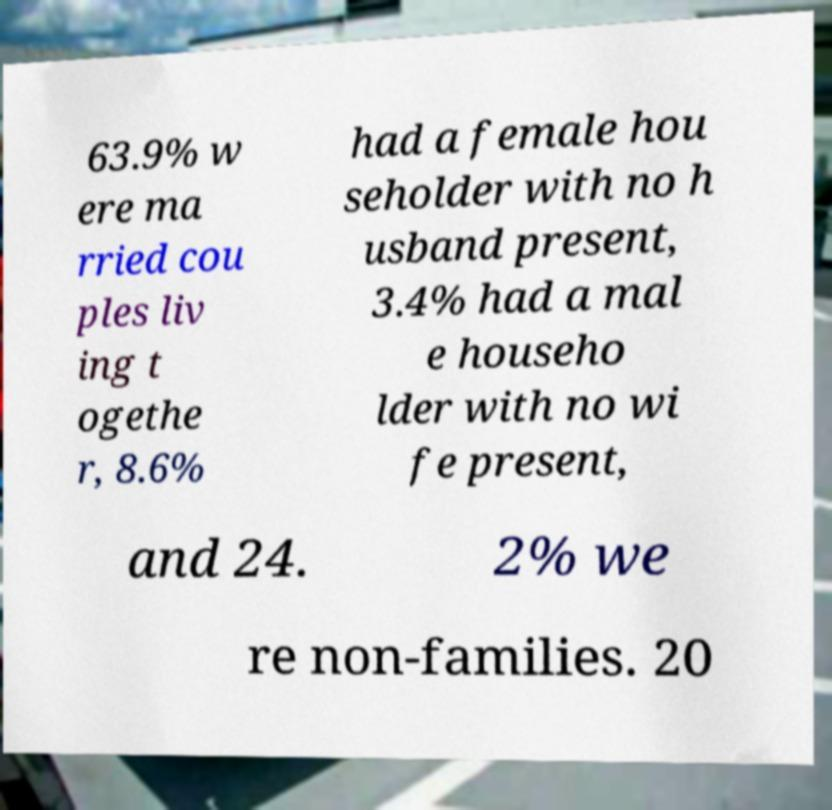Please identify and transcribe the text found in this image. 63.9% w ere ma rried cou ples liv ing t ogethe r, 8.6% had a female hou seholder with no h usband present, 3.4% had a mal e househo lder with no wi fe present, and 24. 2% we re non-families. 20 